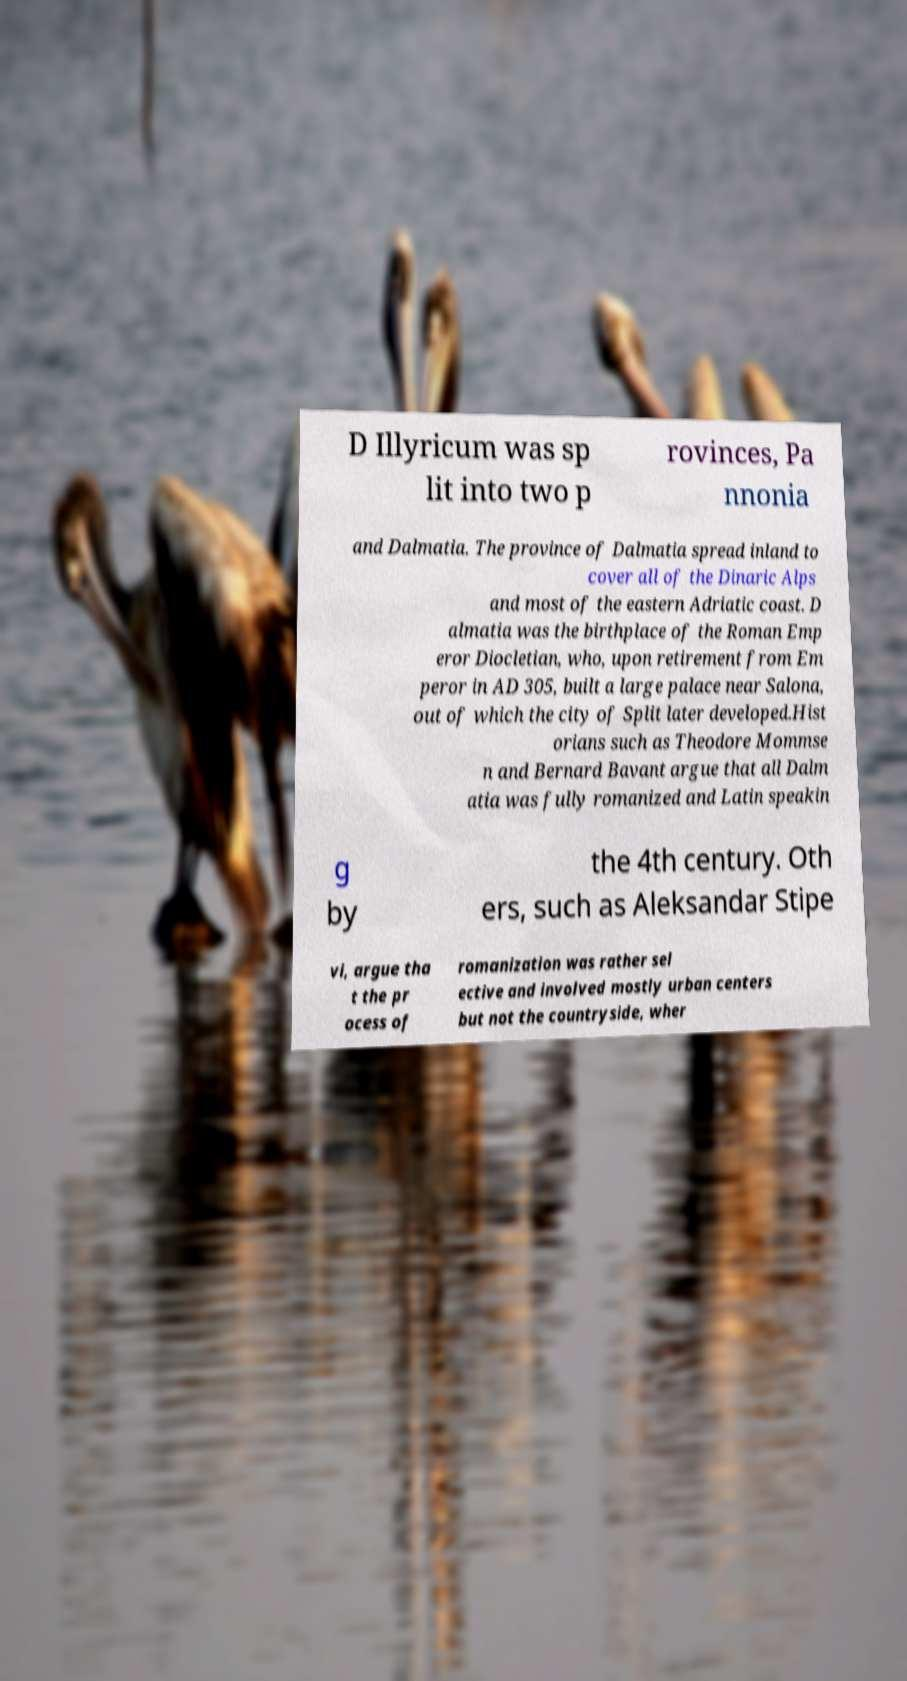Could you extract and type out the text from this image? D Illyricum was sp lit into two p rovinces, Pa nnonia and Dalmatia. The province of Dalmatia spread inland to cover all of the Dinaric Alps and most of the eastern Adriatic coast. D almatia was the birthplace of the Roman Emp eror Diocletian, who, upon retirement from Em peror in AD 305, built a large palace near Salona, out of which the city of Split later developed.Hist orians such as Theodore Mommse n and Bernard Bavant argue that all Dalm atia was fully romanized and Latin speakin g by the 4th century. Oth ers, such as Aleksandar Stipe vi, argue tha t the pr ocess of romanization was rather sel ective and involved mostly urban centers but not the countryside, wher 